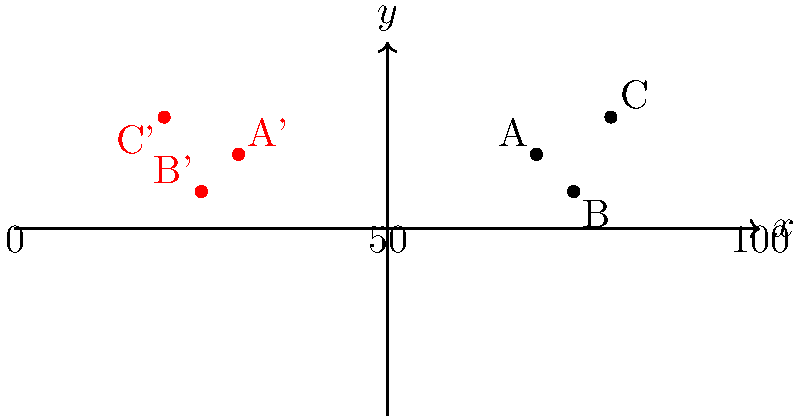Your team is practicing a new formation with players A, B, and C positioned as shown on the right side of the field. You want to mirror this formation on the left side of the field for a balanced play. If you reflect the formation across the 50-yard line (represented by the y-axis), what will be the coordinates of player B' (the reflection of player B)? To find the coordinates of player B' after reflection across the 50-yard line (y-axis), we can follow these steps:

1. Identify the original coordinates of player B:
   Player B is at (25, 5)

2. Understand the reflection rule:
   When reflecting across the y-axis (50-yard line), the x-coordinate changes sign, while the y-coordinate remains the same.

3. Apply the reflection:
   - Original x-coordinate: 25
   - Reflected x-coordinate: -25 (change sign)
   - y-coordinate: 5 (remains the same)

4. Write the new coordinates:
   Player B' will be at (-25, 5)

The reflection across the 50-yard line (y-axis) moves player B from the right side of the field to the left side, maintaining the same distance from the 50-yard line and the same vertical position.
Answer: (-25, 5) 